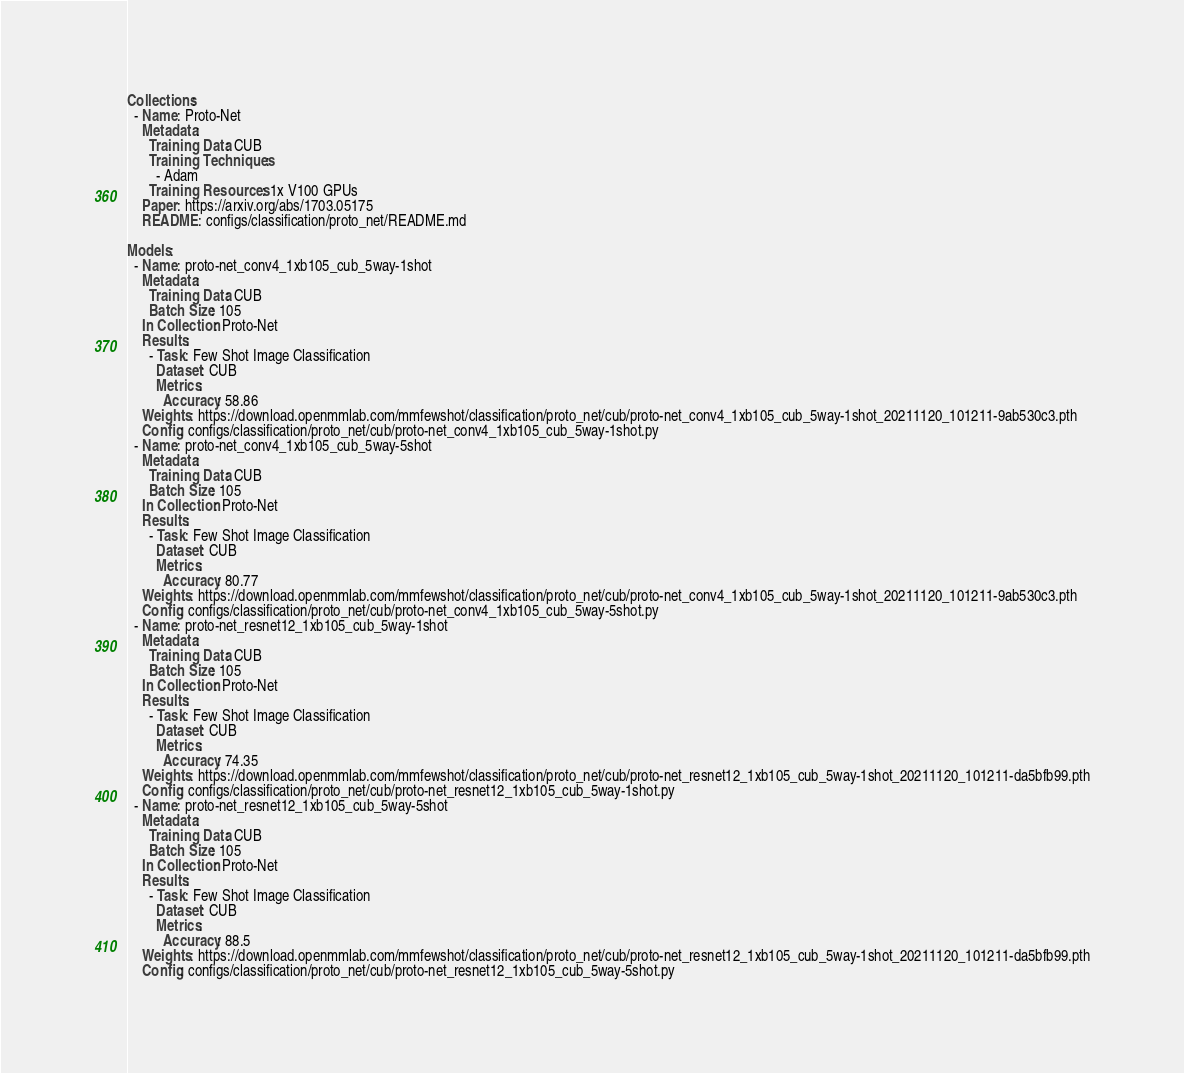Convert code to text. <code><loc_0><loc_0><loc_500><loc_500><_YAML_>Collections:
  - Name: Proto-Net
    Metadata:
      Training Data: CUB
      Training Techniques:
        - Adam
      Training Resources: 1x V100 GPUs
    Paper: https://arxiv.org/abs/1703.05175
    README: configs/classification/proto_net/README.md

Models:
  - Name: proto-net_conv4_1xb105_cub_5way-1shot
    Metadata:
      Training Data: CUB
      Batch Size: 105
    In Collection: Proto-Net
    Results:
      - Task: Few Shot Image Classification
        Dataset: CUB
        Metrics:
          Accuracy: 58.86
    Weights: https://download.openmmlab.com/mmfewshot/classification/proto_net/cub/proto-net_conv4_1xb105_cub_5way-1shot_20211120_101211-9ab530c3.pth
    Config: configs/classification/proto_net/cub/proto-net_conv4_1xb105_cub_5way-1shot.py
  - Name: proto-net_conv4_1xb105_cub_5way-5shot
    Metadata:
      Training Data: CUB
      Batch Size: 105
    In Collection: Proto-Net
    Results:
      - Task: Few Shot Image Classification
        Dataset: CUB
        Metrics:
          Accuracy: 80.77
    Weights: https://download.openmmlab.com/mmfewshot/classification/proto_net/cub/proto-net_conv4_1xb105_cub_5way-1shot_20211120_101211-9ab530c3.pth
    Config: configs/classification/proto_net/cub/proto-net_conv4_1xb105_cub_5way-5shot.py
  - Name: proto-net_resnet12_1xb105_cub_5way-1shot
    Metadata:
      Training Data: CUB
      Batch Size: 105
    In Collection: Proto-Net
    Results:
      - Task: Few Shot Image Classification
        Dataset: CUB
        Metrics:
          Accuracy: 74.35
    Weights: https://download.openmmlab.com/mmfewshot/classification/proto_net/cub/proto-net_resnet12_1xb105_cub_5way-1shot_20211120_101211-da5bfb99.pth
    Config: configs/classification/proto_net/cub/proto-net_resnet12_1xb105_cub_5way-1shot.py
  - Name: proto-net_resnet12_1xb105_cub_5way-5shot
    Metadata:
      Training Data: CUB
      Batch Size: 105
    In Collection: Proto-Net
    Results:
      - Task: Few Shot Image Classification
        Dataset: CUB
        Metrics:
          Accuracy: 88.5
    Weights: https://download.openmmlab.com/mmfewshot/classification/proto_net/cub/proto-net_resnet12_1xb105_cub_5way-1shot_20211120_101211-da5bfb99.pth
    Config: configs/classification/proto_net/cub/proto-net_resnet12_1xb105_cub_5way-5shot.py
</code> 